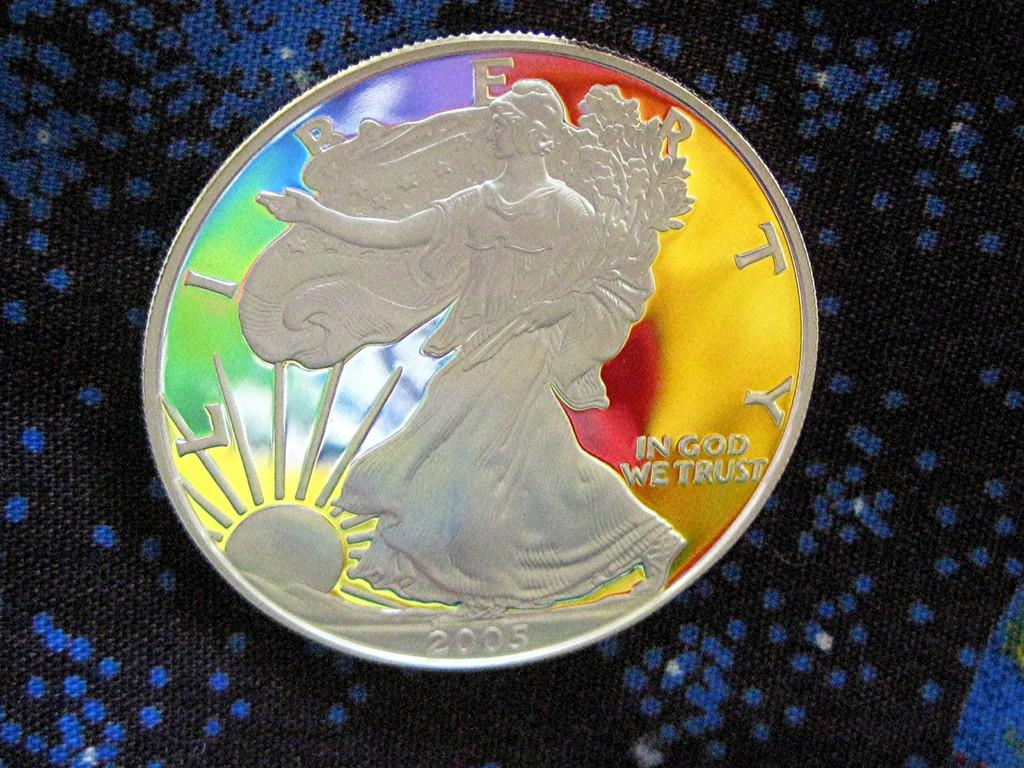What is the main subject of the image? The main subject of the image is a colorful coin. Can you describe the surface on which the coin is placed? The coin is on a black and blue color surface. What type of whip is being used to prepare the stew in the image? There is no whip or stew present in the image; it only features a colorful coin on a black and blue surface. 